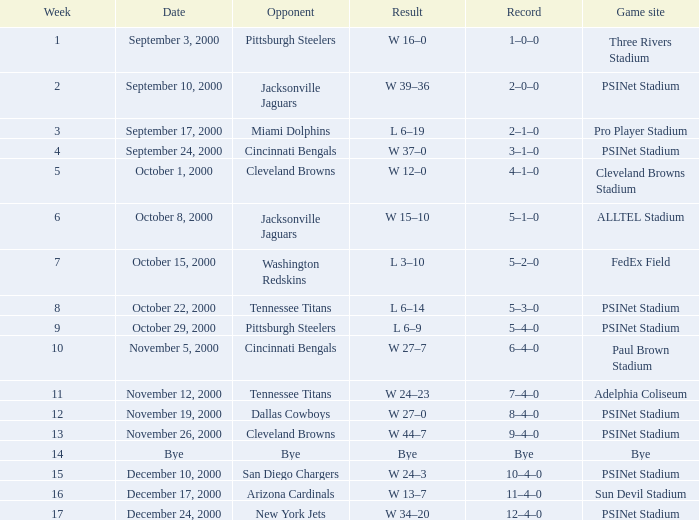What's the record for October 8, 2000 before week 13? 5–1–0. 